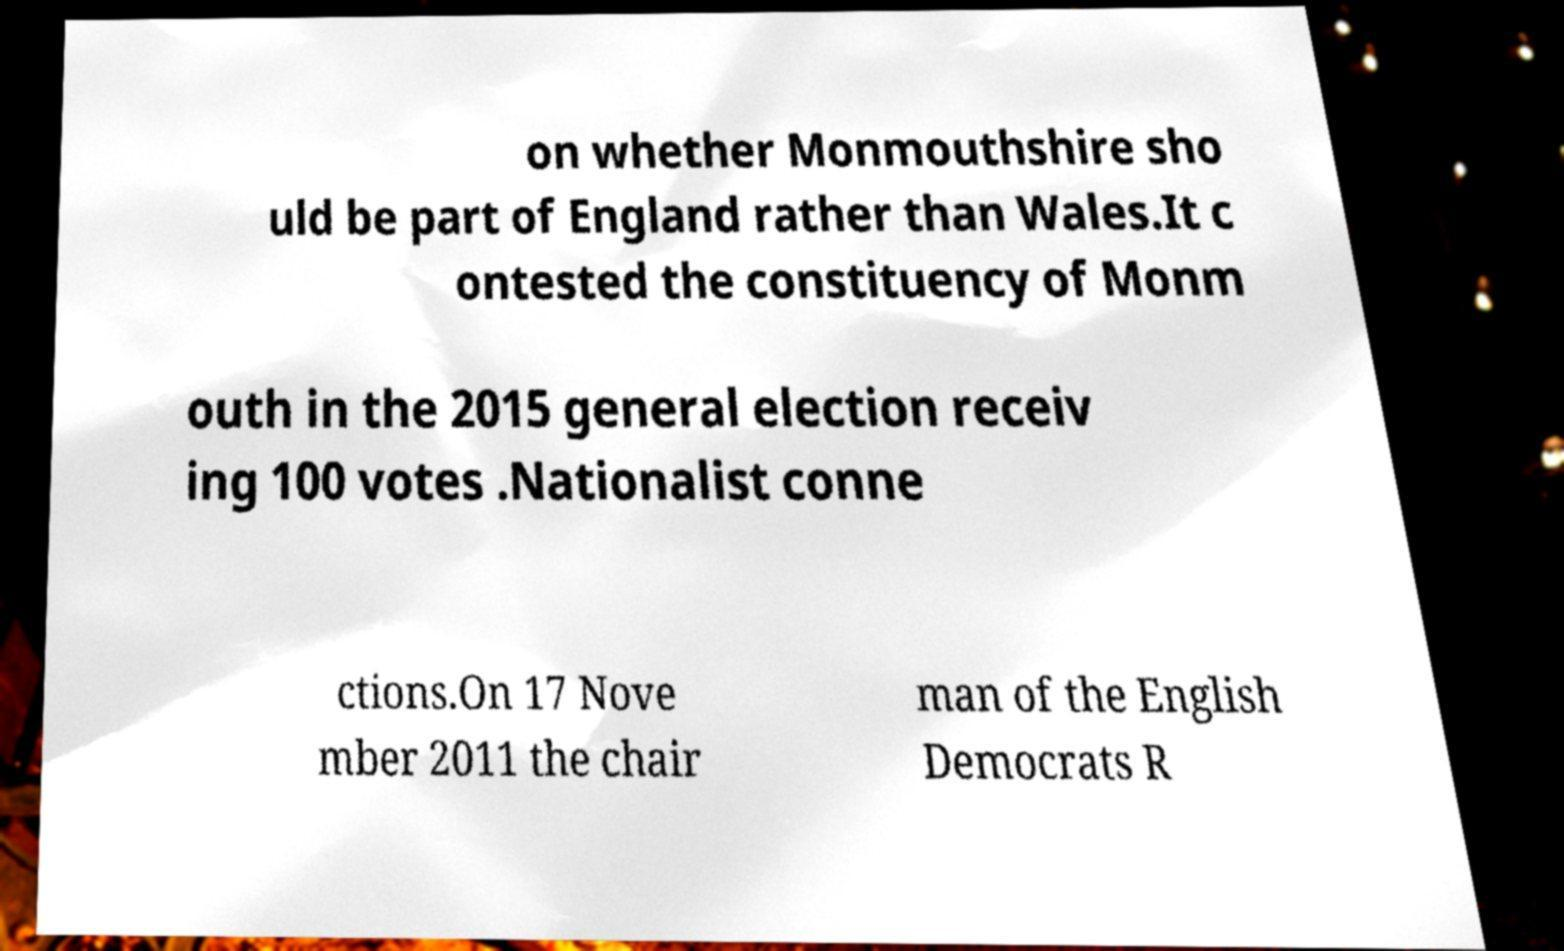I need the written content from this picture converted into text. Can you do that? on whether Monmouthshire sho uld be part of England rather than Wales.It c ontested the constituency of Monm outh in the 2015 general election receiv ing 100 votes .Nationalist conne ctions.On 17 Nove mber 2011 the chair man of the English Democrats R 